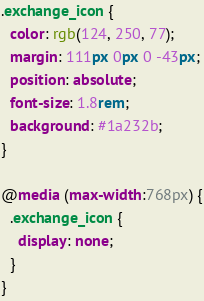Convert code to text. <code><loc_0><loc_0><loc_500><loc_500><_CSS_>.exchange_icon {
  color: rgb(124, 250, 77);
  margin: 111px 0px 0 -43px;
  position: absolute;
  font-size: 1.8rem;
  background: #1a232b;
}

@media (max-width:768px) {
  .exchange_icon {
    display: none;
  }
}
</code> 